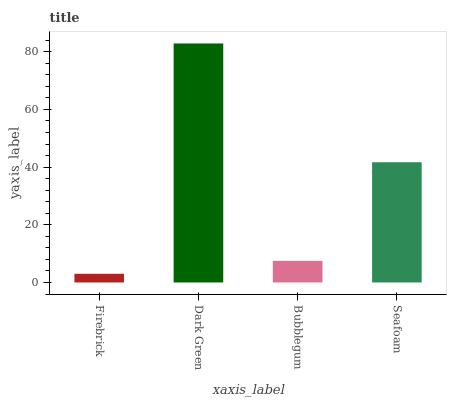Is Bubblegum the minimum?
Answer yes or no. No. Is Bubblegum the maximum?
Answer yes or no. No. Is Dark Green greater than Bubblegum?
Answer yes or no. Yes. Is Bubblegum less than Dark Green?
Answer yes or no. Yes. Is Bubblegum greater than Dark Green?
Answer yes or no. No. Is Dark Green less than Bubblegum?
Answer yes or no. No. Is Seafoam the high median?
Answer yes or no. Yes. Is Bubblegum the low median?
Answer yes or no. Yes. Is Firebrick the high median?
Answer yes or no. No. Is Dark Green the low median?
Answer yes or no. No. 